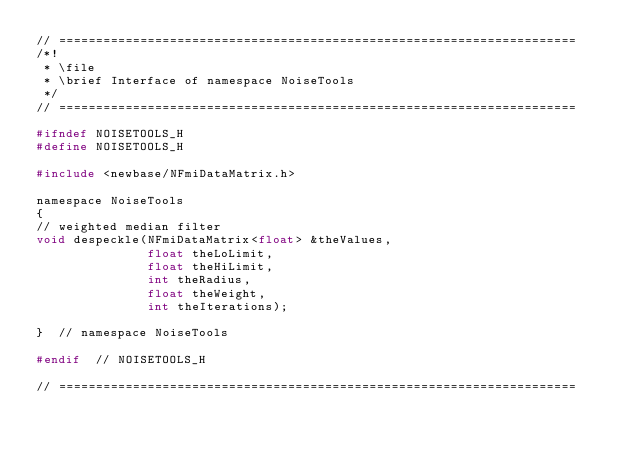Convert code to text. <code><loc_0><loc_0><loc_500><loc_500><_C_>// ======================================================================
/*!
 * \file
 * \brief Interface of namespace NoiseTools
 */
// ======================================================================

#ifndef NOISETOOLS_H
#define NOISETOOLS_H

#include <newbase/NFmiDataMatrix.h>

namespace NoiseTools
{
// weighted median filter
void despeckle(NFmiDataMatrix<float> &theValues,
               float theLoLimit,
               float theHiLimit,
               int theRadius,
               float theWeight,
               int theIterations);

}  // namespace NoiseTools

#endif  // NOISETOOLS_H

// ======================================================================
</code> 